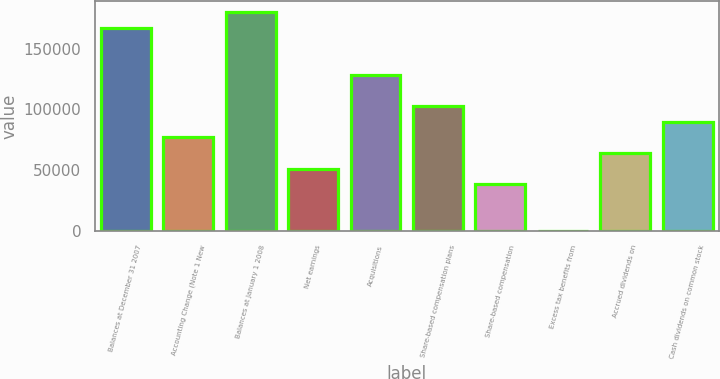Convert chart to OTSL. <chart><loc_0><loc_0><loc_500><loc_500><bar_chart><fcel>Balances at December 31 2007<fcel>Accounting Change (Note 1 New<fcel>Balances at January 1 2008<fcel>Net earnings<fcel>Acquisitions<fcel>Share-based compensation plans<fcel>Share-based compensation<fcel>Excess tax benefits from<fcel>Accrued dividends on<fcel>Cash dividends on common stock<nl><fcel>167140<fcel>77142.9<fcel>179997<fcel>51429.4<fcel>128570<fcel>102856<fcel>38572.6<fcel>2.32<fcel>64286.2<fcel>89999.7<nl></chart> 